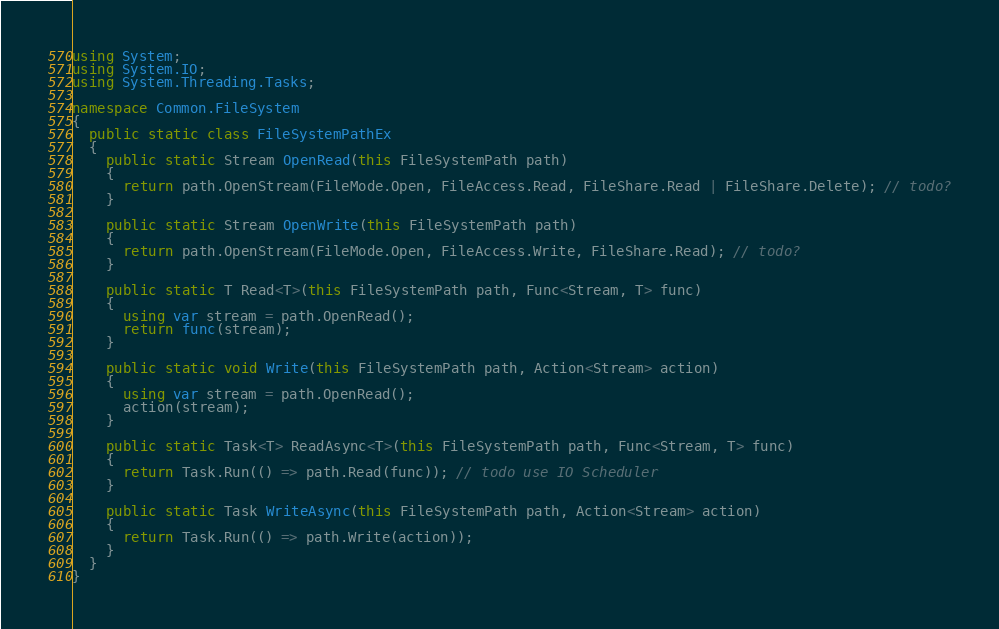<code> <loc_0><loc_0><loc_500><loc_500><_C#_>using System;
using System.IO;
using System.Threading.Tasks;

namespace Common.FileSystem
{
  public static class FileSystemPathEx
  {
    public static Stream OpenRead(this FileSystemPath path)
    {
      return path.OpenStream(FileMode.Open, FileAccess.Read, FileShare.Read | FileShare.Delete); // todo?
    }
    
    public static Stream OpenWrite(this FileSystemPath path)
    {
      return path.OpenStream(FileMode.Open, FileAccess.Write, FileShare.Read); // todo?
    }

    public static T Read<T>(this FileSystemPath path, Func<Stream, T> func)
    {
      using var stream = path.OpenRead();
      return func(stream);
    }
    
    public static void Write(this FileSystemPath path, Action<Stream> action)
    {
      using var stream = path.OpenRead();
      action(stream);
    }

    public static Task<T> ReadAsync<T>(this FileSystemPath path, Func<Stream, T> func)
    {
      return Task.Run(() => path.Read(func)); // todo use IO Scheduler
    }

    public static Task WriteAsync(this FileSystemPath path, Action<Stream> action)
    {
      return Task.Run(() => path.Write(action));
    }
  }
}</code> 